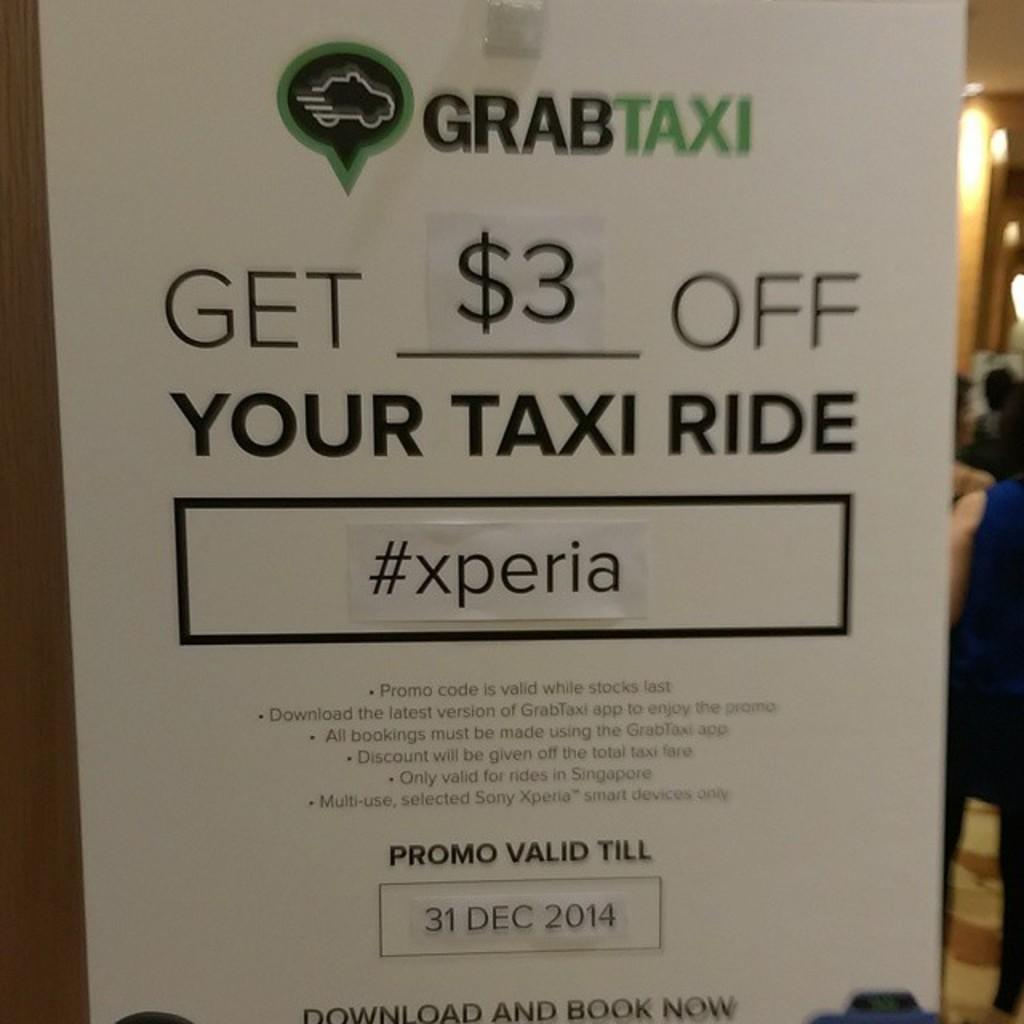<image>
Summarize the visual content of the image. A sign displaying a promotion of $3 off a taxi ride from GrabTaxi. 